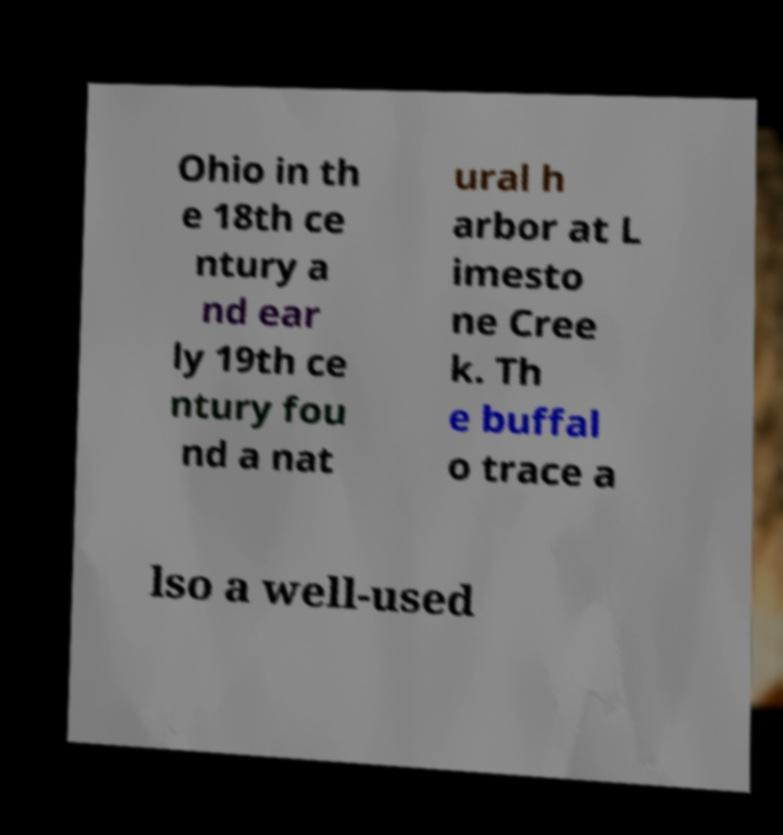Could you extract and type out the text from this image? Ohio in th e 18th ce ntury a nd ear ly 19th ce ntury fou nd a nat ural h arbor at L imesto ne Cree k. Th e buffal o trace a lso a well-used 